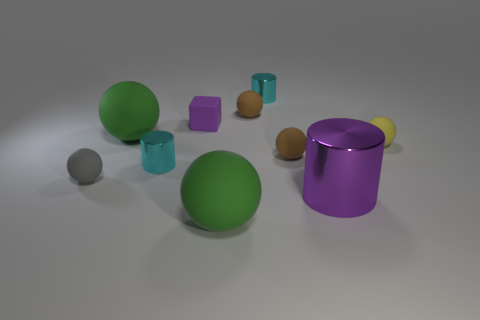Subtract 3 balls. How many balls are left? 3 Subtract all yellow balls. How many balls are left? 5 Subtract all yellow matte spheres. How many spheres are left? 5 Subtract all purple spheres. Subtract all blue blocks. How many spheres are left? 6 Subtract all balls. How many objects are left? 4 Add 2 yellow matte balls. How many yellow matte balls exist? 3 Subtract 1 cyan cylinders. How many objects are left? 9 Subtract all cyan objects. Subtract all small cyan metallic cylinders. How many objects are left? 6 Add 5 gray objects. How many gray objects are left? 6 